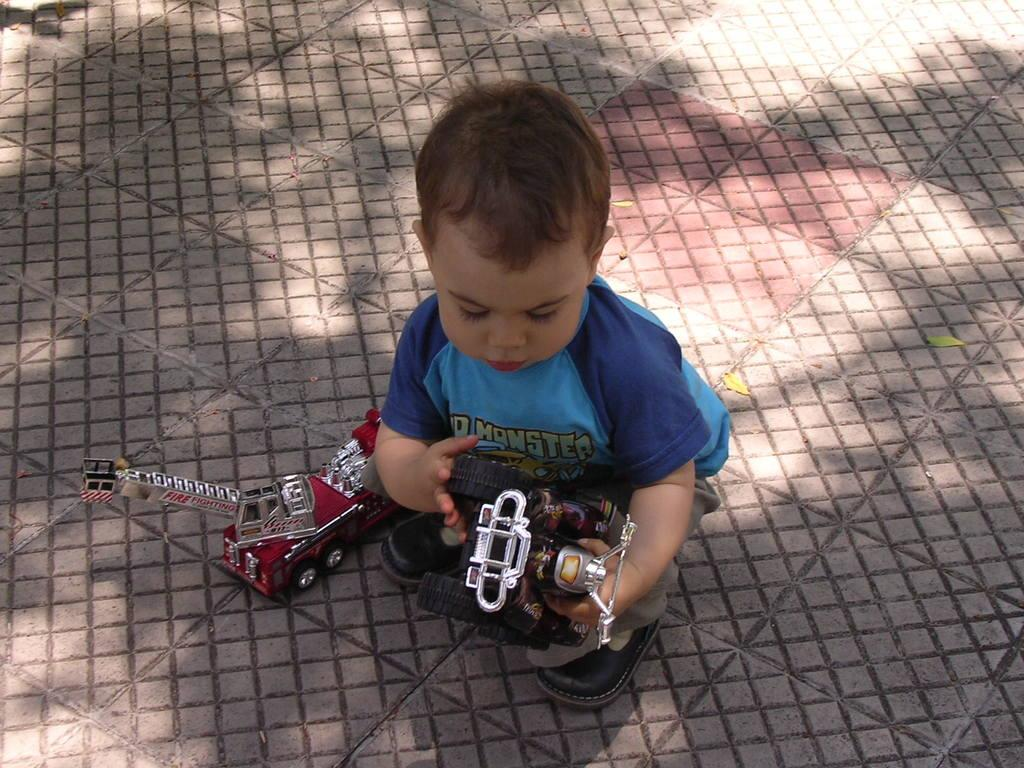What is the main subject of the image? There is a baby in the image. What is the baby wearing? The baby is wearing a blue t-shirt. Where is the baby located in the image? The baby is sitting on the floor. What is the baby doing in the image? The baby is playing with toys. What type of lace can be seen on the baby's t-shirt in the image? There is no lace visible on the baby's t-shirt in the image; it is a plain blue t-shirt. 